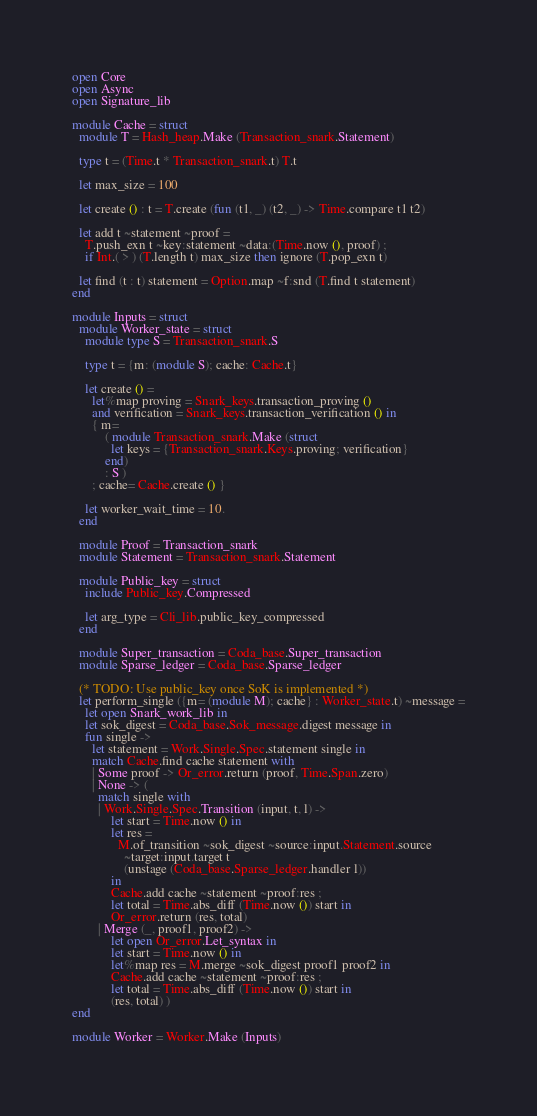<code> <loc_0><loc_0><loc_500><loc_500><_OCaml_>open Core
open Async
open Signature_lib

module Cache = struct
  module T = Hash_heap.Make (Transaction_snark.Statement)

  type t = (Time.t * Transaction_snark.t) T.t

  let max_size = 100

  let create () : t = T.create (fun (t1, _) (t2, _) -> Time.compare t1 t2)

  let add t ~statement ~proof =
    T.push_exn t ~key:statement ~data:(Time.now (), proof) ;
    if Int.( > ) (T.length t) max_size then ignore (T.pop_exn t)

  let find (t : t) statement = Option.map ~f:snd (T.find t statement)
end

module Inputs = struct
  module Worker_state = struct
    module type S = Transaction_snark.S

    type t = {m: (module S); cache: Cache.t}

    let create () =
      let%map proving = Snark_keys.transaction_proving ()
      and verification = Snark_keys.transaction_verification () in
      { m=
          ( module Transaction_snark.Make (struct
            let keys = {Transaction_snark.Keys.proving; verification}
          end)
          : S )
      ; cache= Cache.create () }

    let worker_wait_time = 10.
  end

  module Proof = Transaction_snark
  module Statement = Transaction_snark.Statement

  module Public_key = struct
    include Public_key.Compressed

    let arg_type = Cli_lib.public_key_compressed
  end

  module Super_transaction = Coda_base.Super_transaction
  module Sparse_ledger = Coda_base.Sparse_ledger

  (* TODO: Use public_key once SoK is implemented *)
  let perform_single ({m= (module M); cache} : Worker_state.t) ~message =
    let open Snark_work_lib in
    let sok_digest = Coda_base.Sok_message.digest message in
    fun single ->
      let statement = Work.Single.Spec.statement single in
      match Cache.find cache statement with
      | Some proof -> Or_error.return (proof, Time.Span.zero)
      | None -> (
        match single with
        | Work.Single.Spec.Transition (input, t, l) ->
            let start = Time.now () in
            let res =
              M.of_transition ~sok_digest ~source:input.Statement.source
                ~target:input.target t
                (unstage (Coda_base.Sparse_ledger.handler l))
            in
            Cache.add cache ~statement ~proof:res ;
            let total = Time.abs_diff (Time.now ()) start in
            Or_error.return (res, total)
        | Merge (_, proof1, proof2) ->
            let open Or_error.Let_syntax in
            let start = Time.now () in
            let%map res = M.merge ~sok_digest proof1 proof2 in
            Cache.add cache ~statement ~proof:res ;
            let total = Time.abs_diff (Time.now ()) start in
            (res, total) )
end

module Worker = Worker.Make (Inputs)
</code> 